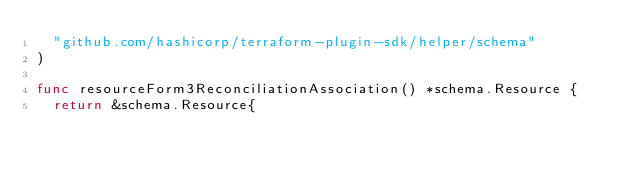<code> <loc_0><loc_0><loc_500><loc_500><_Go_>	"github.com/hashicorp/terraform-plugin-sdk/helper/schema"
)

func resourceForm3ReconciliationAssociation() *schema.Resource {
	return &schema.Resource{</code> 